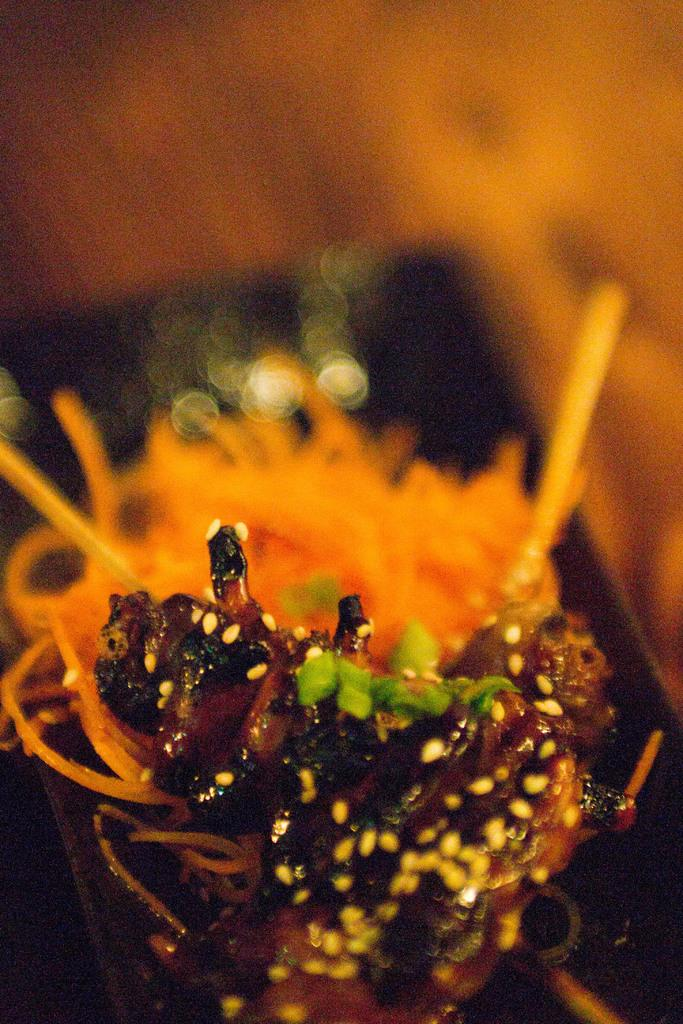What is the main subject of the image? The main subject of the image is an insect on a flower. What can be seen in the background of the image? The background of the image includes orange and black colors. What type of flesh can be seen hanging from the flower in the image? There is no flesh present in the image; it features an insect on a flower. How many bikes are visible in the image? There are no bikes present in the image. 